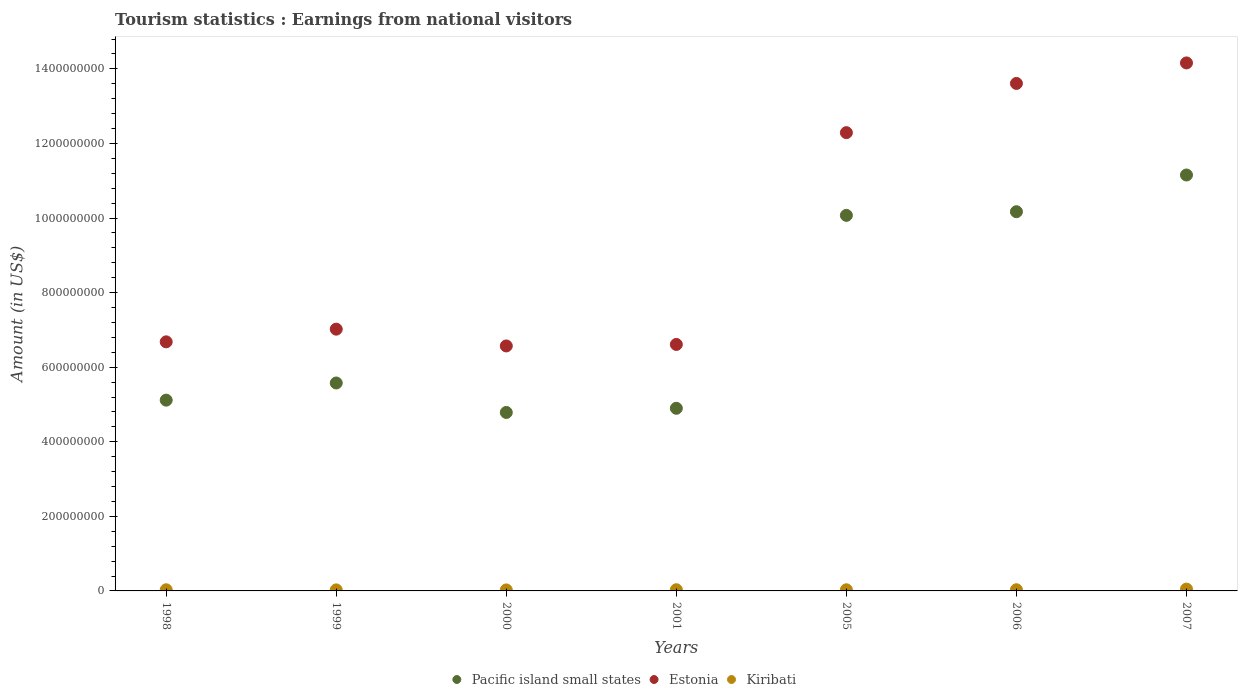How many different coloured dotlines are there?
Provide a short and direct response. 3. What is the earnings from national visitors in Pacific island small states in 2006?
Ensure brevity in your answer.  1.02e+09. Across all years, what is the maximum earnings from national visitors in Pacific island small states?
Keep it short and to the point. 1.12e+09. Across all years, what is the minimum earnings from national visitors in Estonia?
Your answer should be compact. 6.57e+08. In which year was the earnings from national visitors in Estonia maximum?
Offer a very short reply. 2007. In which year was the earnings from national visitors in Pacific island small states minimum?
Your response must be concise. 2000. What is the total earnings from national visitors in Estonia in the graph?
Offer a terse response. 6.69e+09. What is the difference between the earnings from national visitors in Pacific island small states in 1998 and that in 2006?
Ensure brevity in your answer.  -5.05e+08. What is the difference between the earnings from national visitors in Pacific island small states in 1998 and the earnings from national visitors in Kiribati in 2005?
Offer a very short reply. 5.09e+08. What is the average earnings from national visitors in Pacific island small states per year?
Your answer should be very brief. 7.40e+08. In the year 2000, what is the difference between the earnings from national visitors in Estonia and earnings from national visitors in Kiribati?
Your answer should be compact. 6.54e+08. What is the ratio of the earnings from national visitors in Estonia in 1999 to that in 2000?
Offer a terse response. 1.07. Is the difference between the earnings from national visitors in Estonia in 1998 and 2007 greater than the difference between the earnings from national visitors in Kiribati in 1998 and 2007?
Offer a terse response. No. What is the difference between the highest and the second highest earnings from national visitors in Estonia?
Your answer should be compact. 5.50e+07. What is the difference between the highest and the lowest earnings from national visitors in Estonia?
Provide a succinct answer. 7.59e+08. Is the sum of the earnings from national visitors in Estonia in 2000 and 2006 greater than the maximum earnings from national visitors in Pacific island small states across all years?
Give a very brief answer. Yes. Is the earnings from national visitors in Kiribati strictly greater than the earnings from national visitors in Estonia over the years?
Your answer should be compact. No. Is the earnings from national visitors in Estonia strictly less than the earnings from national visitors in Kiribati over the years?
Make the answer very short. No. What is the difference between two consecutive major ticks on the Y-axis?
Your answer should be very brief. 2.00e+08. Are the values on the major ticks of Y-axis written in scientific E-notation?
Provide a short and direct response. No. Where does the legend appear in the graph?
Offer a very short reply. Bottom center. How many legend labels are there?
Your answer should be very brief. 3. How are the legend labels stacked?
Make the answer very short. Horizontal. What is the title of the graph?
Give a very brief answer. Tourism statistics : Earnings from national visitors. What is the Amount (in US$) of Pacific island small states in 1998?
Give a very brief answer. 5.12e+08. What is the Amount (in US$) of Estonia in 1998?
Your response must be concise. 6.68e+08. What is the Amount (in US$) in Kiribati in 1998?
Keep it short and to the point. 3.10e+06. What is the Amount (in US$) in Pacific island small states in 1999?
Your response must be concise. 5.58e+08. What is the Amount (in US$) in Estonia in 1999?
Keep it short and to the point. 7.02e+08. What is the Amount (in US$) in Kiribati in 1999?
Offer a very short reply. 2.80e+06. What is the Amount (in US$) in Pacific island small states in 2000?
Keep it short and to the point. 4.79e+08. What is the Amount (in US$) of Estonia in 2000?
Make the answer very short. 6.57e+08. What is the Amount (in US$) of Kiribati in 2000?
Keep it short and to the point. 2.70e+06. What is the Amount (in US$) in Pacific island small states in 2001?
Ensure brevity in your answer.  4.90e+08. What is the Amount (in US$) of Estonia in 2001?
Give a very brief answer. 6.61e+08. What is the Amount (in US$) in Kiribati in 2001?
Offer a very short reply. 3.20e+06. What is the Amount (in US$) of Pacific island small states in 2005?
Offer a very short reply. 1.01e+09. What is the Amount (in US$) in Estonia in 2005?
Provide a short and direct response. 1.23e+09. What is the Amount (in US$) in Kiribati in 2005?
Provide a short and direct response. 3.10e+06. What is the Amount (in US$) in Pacific island small states in 2006?
Provide a succinct answer. 1.02e+09. What is the Amount (in US$) in Estonia in 2006?
Offer a very short reply. 1.36e+09. What is the Amount (in US$) of Kiribati in 2006?
Provide a succinct answer. 3.20e+06. What is the Amount (in US$) in Pacific island small states in 2007?
Offer a very short reply. 1.12e+09. What is the Amount (in US$) in Estonia in 2007?
Make the answer very short. 1.42e+09. What is the Amount (in US$) of Kiribati in 2007?
Your response must be concise. 4.90e+06. Across all years, what is the maximum Amount (in US$) of Pacific island small states?
Keep it short and to the point. 1.12e+09. Across all years, what is the maximum Amount (in US$) in Estonia?
Give a very brief answer. 1.42e+09. Across all years, what is the maximum Amount (in US$) in Kiribati?
Ensure brevity in your answer.  4.90e+06. Across all years, what is the minimum Amount (in US$) in Pacific island small states?
Your answer should be compact. 4.79e+08. Across all years, what is the minimum Amount (in US$) in Estonia?
Provide a short and direct response. 6.57e+08. Across all years, what is the minimum Amount (in US$) of Kiribati?
Keep it short and to the point. 2.70e+06. What is the total Amount (in US$) in Pacific island small states in the graph?
Provide a short and direct response. 5.18e+09. What is the total Amount (in US$) in Estonia in the graph?
Make the answer very short. 6.69e+09. What is the total Amount (in US$) of Kiribati in the graph?
Provide a succinct answer. 2.30e+07. What is the difference between the Amount (in US$) in Pacific island small states in 1998 and that in 1999?
Provide a succinct answer. -4.60e+07. What is the difference between the Amount (in US$) in Estonia in 1998 and that in 1999?
Your response must be concise. -3.40e+07. What is the difference between the Amount (in US$) of Pacific island small states in 1998 and that in 2000?
Ensure brevity in your answer.  3.30e+07. What is the difference between the Amount (in US$) of Estonia in 1998 and that in 2000?
Your answer should be compact. 1.10e+07. What is the difference between the Amount (in US$) of Kiribati in 1998 and that in 2000?
Keep it short and to the point. 4.00e+05. What is the difference between the Amount (in US$) of Pacific island small states in 1998 and that in 2001?
Ensure brevity in your answer.  2.19e+07. What is the difference between the Amount (in US$) in Estonia in 1998 and that in 2001?
Offer a terse response. 7.00e+06. What is the difference between the Amount (in US$) of Kiribati in 1998 and that in 2001?
Your answer should be compact. -1.00e+05. What is the difference between the Amount (in US$) of Pacific island small states in 1998 and that in 2005?
Ensure brevity in your answer.  -4.96e+08. What is the difference between the Amount (in US$) in Estonia in 1998 and that in 2005?
Ensure brevity in your answer.  -5.61e+08. What is the difference between the Amount (in US$) of Pacific island small states in 1998 and that in 2006?
Make the answer very short. -5.05e+08. What is the difference between the Amount (in US$) of Estonia in 1998 and that in 2006?
Ensure brevity in your answer.  -6.93e+08. What is the difference between the Amount (in US$) in Kiribati in 1998 and that in 2006?
Make the answer very short. -1.00e+05. What is the difference between the Amount (in US$) in Pacific island small states in 1998 and that in 2007?
Make the answer very short. -6.04e+08. What is the difference between the Amount (in US$) of Estonia in 1998 and that in 2007?
Your answer should be very brief. -7.48e+08. What is the difference between the Amount (in US$) of Kiribati in 1998 and that in 2007?
Offer a very short reply. -1.80e+06. What is the difference between the Amount (in US$) in Pacific island small states in 1999 and that in 2000?
Make the answer very short. 7.90e+07. What is the difference between the Amount (in US$) of Estonia in 1999 and that in 2000?
Provide a succinct answer. 4.50e+07. What is the difference between the Amount (in US$) of Pacific island small states in 1999 and that in 2001?
Your answer should be very brief. 6.78e+07. What is the difference between the Amount (in US$) in Estonia in 1999 and that in 2001?
Provide a short and direct response. 4.10e+07. What is the difference between the Amount (in US$) of Kiribati in 1999 and that in 2001?
Make the answer very short. -4.00e+05. What is the difference between the Amount (in US$) of Pacific island small states in 1999 and that in 2005?
Offer a very short reply. -4.50e+08. What is the difference between the Amount (in US$) in Estonia in 1999 and that in 2005?
Offer a very short reply. -5.27e+08. What is the difference between the Amount (in US$) in Pacific island small states in 1999 and that in 2006?
Your answer should be very brief. -4.59e+08. What is the difference between the Amount (in US$) in Estonia in 1999 and that in 2006?
Keep it short and to the point. -6.59e+08. What is the difference between the Amount (in US$) in Kiribati in 1999 and that in 2006?
Offer a terse response. -4.00e+05. What is the difference between the Amount (in US$) of Pacific island small states in 1999 and that in 2007?
Your response must be concise. -5.58e+08. What is the difference between the Amount (in US$) in Estonia in 1999 and that in 2007?
Ensure brevity in your answer.  -7.14e+08. What is the difference between the Amount (in US$) of Kiribati in 1999 and that in 2007?
Offer a terse response. -2.10e+06. What is the difference between the Amount (in US$) of Pacific island small states in 2000 and that in 2001?
Your answer should be very brief. -1.12e+07. What is the difference between the Amount (in US$) of Kiribati in 2000 and that in 2001?
Provide a succinct answer. -5.00e+05. What is the difference between the Amount (in US$) in Pacific island small states in 2000 and that in 2005?
Your response must be concise. -5.29e+08. What is the difference between the Amount (in US$) in Estonia in 2000 and that in 2005?
Keep it short and to the point. -5.72e+08. What is the difference between the Amount (in US$) of Kiribati in 2000 and that in 2005?
Your answer should be very brief. -4.00e+05. What is the difference between the Amount (in US$) of Pacific island small states in 2000 and that in 2006?
Your answer should be very brief. -5.38e+08. What is the difference between the Amount (in US$) in Estonia in 2000 and that in 2006?
Your response must be concise. -7.04e+08. What is the difference between the Amount (in US$) in Kiribati in 2000 and that in 2006?
Offer a terse response. -5.00e+05. What is the difference between the Amount (in US$) of Pacific island small states in 2000 and that in 2007?
Provide a short and direct response. -6.37e+08. What is the difference between the Amount (in US$) of Estonia in 2000 and that in 2007?
Your response must be concise. -7.59e+08. What is the difference between the Amount (in US$) in Kiribati in 2000 and that in 2007?
Offer a very short reply. -2.20e+06. What is the difference between the Amount (in US$) of Pacific island small states in 2001 and that in 2005?
Keep it short and to the point. -5.17e+08. What is the difference between the Amount (in US$) in Estonia in 2001 and that in 2005?
Keep it short and to the point. -5.68e+08. What is the difference between the Amount (in US$) of Kiribati in 2001 and that in 2005?
Keep it short and to the point. 1.00e+05. What is the difference between the Amount (in US$) in Pacific island small states in 2001 and that in 2006?
Provide a succinct answer. -5.27e+08. What is the difference between the Amount (in US$) of Estonia in 2001 and that in 2006?
Your answer should be compact. -7.00e+08. What is the difference between the Amount (in US$) in Pacific island small states in 2001 and that in 2007?
Ensure brevity in your answer.  -6.26e+08. What is the difference between the Amount (in US$) of Estonia in 2001 and that in 2007?
Ensure brevity in your answer.  -7.55e+08. What is the difference between the Amount (in US$) of Kiribati in 2001 and that in 2007?
Your answer should be very brief. -1.70e+06. What is the difference between the Amount (in US$) in Pacific island small states in 2005 and that in 2006?
Ensure brevity in your answer.  -9.77e+06. What is the difference between the Amount (in US$) of Estonia in 2005 and that in 2006?
Your answer should be very brief. -1.32e+08. What is the difference between the Amount (in US$) of Kiribati in 2005 and that in 2006?
Provide a short and direct response. -1.00e+05. What is the difference between the Amount (in US$) in Pacific island small states in 2005 and that in 2007?
Offer a very short reply. -1.08e+08. What is the difference between the Amount (in US$) of Estonia in 2005 and that in 2007?
Give a very brief answer. -1.87e+08. What is the difference between the Amount (in US$) of Kiribati in 2005 and that in 2007?
Keep it short and to the point. -1.80e+06. What is the difference between the Amount (in US$) of Pacific island small states in 2006 and that in 2007?
Your response must be concise. -9.85e+07. What is the difference between the Amount (in US$) in Estonia in 2006 and that in 2007?
Ensure brevity in your answer.  -5.50e+07. What is the difference between the Amount (in US$) in Kiribati in 2006 and that in 2007?
Give a very brief answer. -1.70e+06. What is the difference between the Amount (in US$) of Pacific island small states in 1998 and the Amount (in US$) of Estonia in 1999?
Your answer should be compact. -1.90e+08. What is the difference between the Amount (in US$) of Pacific island small states in 1998 and the Amount (in US$) of Kiribati in 1999?
Ensure brevity in your answer.  5.09e+08. What is the difference between the Amount (in US$) of Estonia in 1998 and the Amount (in US$) of Kiribati in 1999?
Provide a short and direct response. 6.65e+08. What is the difference between the Amount (in US$) in Pacific island small states in 1998 and the Amount (in US$) in Estonia in 2000?
Your response must be concise. -1.45e+08. What is the difference between the Amount (in US$) in Pacific island small states in 1998 and the Amount (in US$) in Kiribati in 2000?
Your answer should be very brief. 5.09e+08. What is the difference between the Amount (in US$) in Estonia in 1998 and the Amount (in US$) in Kiribati in 2000?
Your answer should be compact. 6.65e+08. What is the difference between the Amount (in US$) of Pacific island small states in 1998 and the Amount (in US$) of Estonia in 2001?
Provide a short and direct response. -1.49e+08. What is the difference between the Amount (in US$) in Pacific island small states in 1998 and the Amount (in US$) in Kiribati in 2001?
Keep it short and to the point. 5.08e+08. What is the difference between the Amount (in US$) of Estonia in 1998 and the Amount (in US$) of Kiribati in 2001?
Keep it short and to the point. 6.65e+08. What is the difference between the Amount (in US$) in Pacific island small states in 1998 and the Amount (in US$) in Estonia in 2005?
Make the answer very short. -7.17e+08. What is the difference between the Amount (in US$) in Pacific island small states in 1998 and the Amount (in US$) in Kiribati in 2005?
Your response must be concise. 5.09e+08. What is the difference between the Amount (in US$) in Estonia in 1998 and the Amount (in US$) in Kiribati in 2005?
Make the answer very short. 6.65e+08. What is the difference between the Amount (in US$) of Pacific island small states in 1998 and the Amount (in US$) of Estonia in 2006?
Keep it short and to the point. -8.49e+08. What is the difference between the Amount (in US$) in Pacific island small states in 1998 and the Amount (in US$) in Kiribati in 2006?
Offer a very short reply. 5.08e+08. What is the difference between the Amount (in US$) of Estonia in 1998 and the Amount (in US$) of Kiribati in 2006?
Your response must be concise. 6.65e+08. What is the difference between the Amount (in US$) of Pacific island small states in 1998 and the Amount (in US$) of Estonia in 2007?
Keep it short and to the point. -9.04e+08. What is the difference between the Amount (in US$) of Pacific island small states in 1998 and the Amount (in US$) of Kiribati in 2007?
Your response must be concise. 5.07e+08. What is the difference between the Amount (in US$) in Estonia in 1998 and the Amount (in US$) in Kiribati in 2007?
Provide a succinct answer. 6.63e+08. What is the difference between the Amount (in US$) in Pacific island small states in 1999 and the Amount (in US$) in Estonia in 2000?
Keep it short and to the point. -9.94e+07. What is the difference between the Amount (in US$) of Pacific island small states in 1999 and the Amount (in US$) of Kiribati in 2000?
Give a very brief answer. 5.55e+08. What is the difference between the Amount (in US$) in Estonia in 1999 and the Amount (in US$) in Kiribati in 2000?
Your response must be concise. 6.99e+08. What is the difference between the Amount (in US$) of Pacific island small states in 1999 and the Amount (in US$) of Estonia in 2001?
Your answer should be compact. -1.03e+08. What is the difference between the Amount (in US$) of Pacific island small states in 1999 and the Amount (in US$) of Kiribati in 2001?
Make the answer very short. 5.54e+08. What is the difference between the Amount (in US$) of Estonia in 1999 and the Amount (in US$) of Kiribati in 2001?
Provide a succinct answer. 6.99e+08. What is the difference between the Amount (in US$) of Pacific island small states in 1999 and the Amount (in US$) of Estonia in 2005?
Provide a short and direct response. -6.71e+08. What is the difference between the Amount (in US$) of Pacific island small states in 1999 and the Amount (in US$) of Kiribati in 2005?
Ensure brevity in your answer.  5.55e+08. What is the difference between the Amount (in US$) of Estonia in 1999 and the Amount (in US$) of Kiribati in 2005?
Offer a terse response. 6.99e+08. What is the difference between the Amount (in US$) of Pacific island small states in 1999 and the Amount (in US$) of Estonia in 2006?
Give a very brief answer. -8.03e+08. What is the difference between the Amount (in US$) of Pacific island small states in 1999 and the Amount (in US$) of Kiribati in 2006?
Make the answer very short. 5.54e+08. What is the difference between the Amount (in US$) in Estonia in 1999 and the Amount (in US$) in Kiribati in 2006?
Make the answer very short. 6.99e+08. What is the difference between the Amount (in US$) in Pacific island small states in 1999 and the Amount (in US$) in Estonia in 2007?
Provide a short and direct response. -8.58e+08. What is the difference between the Amount (in US$) in Pacific island small states in 1999 and the Amount (in US$) in Kiribati in 2007?
Provide a succinct answer. 5.53e+08. What is the difference between the Amount (in US$) in Estonia in 1999 and the Amount (in US$) in Kiribati in 2007?
Offer a very short reply. 6.97e+08. What is the difference between the Amount (in US$) of Pacific island small states in 2000 and the Amount (in US$) of Estonia in 2001?
Give a very brief answer. -1.82e+08. What is the difference between the Amount (in US$) of Pacific island small states in 2000 and the Amount (in US$) of Kiribati in 2001?
Keep it short and to the point. 4.75e+08. What is the difference between the Amount (in US$) of Estonia in 2000 and the Amount (in US$) of Kiribati in 2001?
Give a very brief answer. 6.54e+08. What is the difference between the Amount (in US$) in Pacific island small states in 2000 and the Amount (in US$) in Estonia in 2005?
Give a very brief answer. -7.50e+08. What is the difference between the Amount (in US$) of Pacific island small states in 2000 and the Amount (in US$) of Kiribati in 2005?
Offer a very short reply. 4.76e+08. What is the difference between the Amount (in US$) of Estonia in 2000 and the Amount (in US$) of Kiribati in 2005?
Ensure brevity in your answer.  6.54e+08. What is the difference between the Amount (in US$) of Pacific island small states in 2000 and the Amount (in US$) of Estonia in 2006?
Make the answer very short. -8.82e+08. What is the difference between the Amount (in US$) of Pacific island small states in 2000 and the Amount (in US$) of Kiribati in 2006?
Your response must be concise. 4.75e+08. What is the difference between the Amount (in US$) in Estonia in 2000 and the Amount (in US$) in Kiribati in 2006?
Your answer should be compact. 6.54e+08. What is the difference between the Amount (in US$) of Pacific island small states in 2000 and the Amount (in US$) of Estonia in 2007?
Offer a very short reply. -9.37e+08. What is the difference between the Amount (in US$) in Pacific island small states in 2000 and the Amount (in US$) in Kiribati in 2007?
Keep it short and to the point. 4.74e+08. What is the difference between the Amount (in US$) of Estonia in 2000 and the Amount (in US$) of Kiribati in 2007?
Keep it short and to the point. 6.52e+08. What is the difference between the Amount (in US$) of Pacific island small states in 2001 and the Amount (in US$) of Estonia in 2005?
Make the answer very short. -7.39e+08. What is the difference between the Amount (in US$) in Pacific island small states in 2001 and the Amount (in US$) in Kiribati in 2005?
Make the answer very short. 4.87e+08. What is the difference between the Amount (in US$) of Estonia in 2001 and the Amount (in US$) of Kiribati in 2005?
Make the answer very short. 6.58e+08. What is the difference between the Amount (in US$) of Pacific island small states in 2001 and the Amount (in US$) of Estonia in 2006?
Your answer should be very brief. -8.71e+08. What is the difference between the Amount (in US$) in Pacific island small states in 2001 and the Amount (in US$) in Kiribati in 2006?
Provide a succinct answer. 4.87e+08. What is the difference between the Amount (in US$) of Estonia in 2001 and the Amount (in US$) of Kiribati in 2006?
Ensure brevity in your answer.  6.58e+08. What is the difference between the Amount (in US$) of Pacific island small states in 2001 and the Amount (in US$) of Estonia in 2007?
Your answer should be very brief. -9.26e+08. What is the difference between the Amount (in US$) of Pacific island small states in 2001 and the Amount (in US$) of Kiribati in 2007?
Give a very brief answer. 4.85e+08. What is the difference between the Amount (in US$) in Estonia in 2001 and the Amount (in US$) in Kiribati in 2007?
Give a very brief answer. 6.56e+08. What is the difference between the Amount (in US$) in Pacific island small states in 2005 and the Amount (in US$) in Estonia in 2006?
Your answer should be very brief. -3.54e+08. What is the difference between the Amount (in US$) of Pacific island small states in 2005 and the Amount (in US$) of Kiribati in 2006?
Provide a succinct answer. 1.00e+09. What is the difference between the Amount (in US$) in Estonia in 2005 and the Amount (in US$) in Kiribati in 2006?
Offer a terse response. 1.23e+09. What is the difference between the Amount (in US$) of Pacific island small states in 2005 and the Amount (in US$) of Estonia in 2007?
Give a very brief answer. -4.09e+08. What is the difference between the Amount (in US$) of Pacific island small states in 2005 and the Amount (in US$) of Kiribati in 2007?
Provide a short and direct response. 1.00e+09. What is the difference between the Amount (in US$) in Estonia in 2005 and the Amount (in US$) in Kiribati in 2007?
Offer a terse response. 1.22e+09. What is the difference between the Amount (in US$) of Pacific island small states in 2006 and the Amount (in US$) of Estonia in 2007?
Make the answer very short. -3.99e+08. What is the difference between the Amount (in US$) in Pacific island small states in 2006 and the Amount (in US$) in Kiribati in 2007?
Provide a succinct answer. 1.01e+09. What is the difference between the Amount (in US$) in Estonia in 2006 and the Amount (in US$) in Kiribati in 2007?
Offer a very short reply. 1.36e+09. What is the average Amount (in US$) in Pacific island small states per year?
Your answer should be compact. 7.40e+08. What is the average Amount (in US$) of Estonia per year?
Your response must be concise. 9.56e+08. What is the average Amount (in US$) of Kiribati per year?
Provide a succinct answer. 3.29e+06. In the year 1998, what is the difference between the Amount (in US$) of Pacific island small states and Amount (in US$) of Estonia?
Provide a short and direct response. -1.56e+08. In the year 1998, what is the difference between the Amount (in US$) of Pacific island small states and Amount (in US$) of Kiribati?
Your answer should be very brief. 5.09e+08. In the year 1998, what is the difference between the Amount (in US$) of Estonia and Amount (in US$) of Kiribati?
Make the answer very short. 6.65e+08. In the year 1999, what is the difference between the Amount (in US$) in Pacific island small states and Amount (in US$) in Estonia?
Make the answer very short. -1.44e+08. In the year 1999, what is the difference between the Amount (in US$) of Pacific island small states and Amount (in US$) of Kiribati?
Offer a terse response. 5.55e+08. In the year 1999, what is the difference between the Amount (in US$) in Estonia and Amount (in US$) in Kiribati?
Give a very brief answer. 6.99e+08. In the year 2000, what is the difference between the Amount (in US$) in Pacific island small states and Amount (in US$) in Estonia?
Offer a terse response. -1.78e+08. In the year 2000, what is the difference between the Amount (in US$) of Pacific island small states and Amount (in US$) of Kiribati?
Your response must be concise. 4.76e+08. In the year 2000, what is the difference between the Amount (in US$) of Estonia and Amount (in US$) of Kiribati?
Keep it short and to the point. 6.54e+08. In the year 2001, what is the difference between the Amount (in US$) in Pacific island small states and Amount (in US$) in Estonia?
Offer a very short reply. -1.71e+08. In the year 2001, what is the difference between the Amount (in US$) of Pacific island small states and Amount (in US$) of Kiribati?
Make the answer very short. 4.87e+08. In the year 2001, what is the difference between the Amount (in US$) in Estonia and Amount (in US$) in Kiribati?
Provide a short and direct response. 6.58e+08. In the year 2005, what is the difference between the Amount (in US$) of Pacific island small states and Amount (in US$) of Estonia?
Your answer should be very brief. -2.22e+08. In the year 2005, what is the difference between the Amount (in US$) of Pacific island small states and Amount (in US$) of Kiribati?
Offer a terse response. 1.00e+09. In the year 2005, what is the difference between the Amount (in US$) in Estonia and Amount (in US$) in Kiribati?
Your response must be concise. 1.23e+09. In the year 2006, what is the difference between the Amount (in US$) of Pacific island small states and Amount (in US$) of Estonia?
Your response must be concise. -3.44e+08. In the year 2006, what is the difference between the Amount (in US$) of Pacific island small states and Amount (in US$) of Kiribati?
Offer a very short reply. 1.01e+09. In the year 2006, what is the difference between the Amount (in US$) of Estonia and Amount (in US$) of Kiribati?
Provide a short and direct response. 1.36e+09. In the year 2007, what is the difference between the Amount (in US$) of Pacific island small states and Amount (in US$) of Estonia?
Your answer should be compact. -3.01e+08. In the year 2007, what is the difference between the Amount (in US$) of Pacific island small states and Amount (in US$) of Kiribati?
Keep it short and to the point. 1.11e+09. In the year 2007, what is the difference between the Amount (in US$) in Estonia and Amount (in US$) in Kiribati?
Keep it short and to the point. 1.41e+09. What is the ratio of the Amount (in US$) in Pacific island small states in 1998 to that in 1999?
Offer a very short reply. 0.92. What is the ratio of the Amount (in US$) in Estonia in 1998 to that in 1999?
Make the answer very short. 0.95. What is the ratio of the Amount (in US$) of Kiribati in 1998 to that in 1999?
Your response must be concise. 1.11. What is the ratio of the Amount (in US$) of Pacific island small states in 1998 to that in 2000?
Keep it short and to the point. 1.07. What is the ratio of the Amount (in US$) in Estonia in 1998 to that in 2000?
Make the answer very short. 1.02. What is the ratio of the Amount (in US$) of Kiribati in 1998 to that in 2000?
Make the answer very short. 1.15. What is the ratio of the Amount (in US$) in Pacific island small states in 1998 to that in 2001?
Your answer should be compact. 1.04. What is the ratio of the Amount (in US$) of Estonia in 1998 to that in 2001?
Keep it short and to the point. 1.01. What is the ratio of the Amount (in US$) of Kiribati in 1998 to that in 2001?
Provide a succinct answer. 0.97. What is the ratio of the Amount (in US$) in Pacific island small states in 1998 to that in 2005?
Ensure brevity in your answer.  0.51. What is the ratio of the Amount (in US$) of Estonia in 1998 to that in 2005?
Offer a very short reply. 0.54. What is the ratio of the Amount (in US$) in Pacific island small states in 1998 to that in 2006?
Provide a short and direct response. 0.5. What is the ratio of the Amount (in US$) in Estonia in 1998 to that in 2006?
Offer a terse response. 0.49. What is the ratio of the Amount (in US$) of Kiribati in 1998 to that in 2006?
Your answer should be compact. 0.97. What is the ratio of the Amount (in US$) in Pacific island small states in 1998 to that in 2007?
Your answer should be compact. 0.46. What is the ratio of the Amount (in US$) of Estonia in 1998 to that in 2007?
Offer a terse response. 0.47. What is the ratio of the Amount (in US$) of Kiribati in 1998 to that in 2007?
Offer a very short reply. 0.63. What is the ratio of the Amount (in US$) of Pacific island small states in 1999 to that in 2000?
Provide a succinct answer. 1.17. What is the ratio of the Amount (in US$) of Estonia in 1999 to that in 2000?
Provide a succinct answer. 1.07. What is the ratio of the Amount (in US$) of Kiribati in 1999 to that in 2000?
Offer a very short reply. 1.04. What is the ratio of the Amount (in US$) of Pacific island small states in 1999 to that in 2001?
Your answer should be very brief. 1.14. What is the ratio of the Amount (in US$) in Estonia in 1999 to that in 2001?
Your answer should be very brief. 1.06. What is the ratio of the Amount (in US$) in Kiribati in 1999 to that in 2001?
Your answer should be very brief. 0.88. What is the ratio of the Amount (in US$) of Pacific island small states in 1999 to that in 2005?
Offer a very short reply. 0.55. What is the ratio of the Amount (in US$) in Estonia in 1999 to that in 2005?
Give a very brief answer. 0.57. What is the ratio of the Amount (in US$) of Kiribati in 1999 to that in 2005?
Offer a very short reply. 0.9. What is the ratio of the Amount (in US$) in Pacific island small states in 1999 to that in 2006?
Provide a short and direct response. 0.55. What is the ratio of the Amount (in US$) of Estonia in 1999 to that in 2006?
Your answer should be compact. 0.52. What is the ratio of the Amount (in US$) in Kiribati in 1999 to that in 2006?
Give a very brief answer. 0.88. What is the ratio of the Amount (in US$) of Pacific island small states in 1999 to that in 2007?
Ensure brevity in your answer.  0.5. What is the ratio of the Amount (in US$) of Estonia in 1999 to that in 2007?
Give a very brief answer. 0.5. What is the ratio of the Amount (in US$) of Kiribati in 1999 to that in 2007?
Give a very brief answer. 0.57. What is the ratio of the Amount (in US$) of Pacific island small states in 2000 to that in 2001?
Offer a very short reply. 0.98. What is the ratio of the Amount (in US$) in Kiribati in 2000 to that in 2001?
Keep it short and to the point. 0.84. What is the ratio of the Amount (in US$) of Pacific island small states in 2000 to that in 2005?
Provide a short and direct response. 0.48. What is the ratio of the Amount (in US$) of Estonia in 2000 to that in 2005?
Your response must be concise. 0.53. What is the ratio of the Amount (in US$) in Kiribati in 2000 to that in 2005?
Give a very brief answer. 0.87. What is the ratio of the Amount (in US$) in Pacific island small states in 2000 to that in 2006?
Offer a terse response. 0.47. What is the ratio of the Amount (in US$) of Estonia in 2000 to that in 2006?
Offer a very short reply. 0.48. What is the ratio of the Amount (in US$) in Kiribati in 2000 to that in 2006?
Your answer should be compact. 0.84. What is the ratio of the Amount (in US$) of Pacific island small states in 2000 to that in 2007?
Give a very brief answer. 0.43. What is the ratio of the Amount (in US$) in Estonia in 2000 to that in 2007?
Your response must be concise. 0.46. What is the ratio of the Amount (in US$) in Kiribati in 2000 to that in 2007?
Ensure brevity in your answer.  0.55. What is the ratio of the Amount (in US$) of Pacific island small states in 2001 to that in 2005?
Ensure brevity in your answer.  0.49. What is the ratio of the Amount (in US$) in Estonia in 2001 to that in 2005?
Your response must be concise. 0.54. What is the ratio of the Amount (in US$) in Kiribati in 2001 to that in 2005?
Give a very brief answer. 1.03. What is the ratio of the Amount (in US$) of Pacific island small states in 2001 to that in 2006?
Provide a short and direct response. 0.48. What is the ratio of the Amount (in US$) of Estonia in 2001 to that in 2006?
Your answer should be compact. 0.49. What is the ratio of the Amount (in US$) of Kiribati in 2001 to that in 2006?
Your answer should be very brief. 1. What is the ratio of the Amount (in US$) in Pacific island small states in 2001 to that in 2007?
Offer a terse response. 0.44. What is the ratio of the Amount (in US$) in Estonia in 2001 to that in 2007?
Give a very brief answer. 0.47. What is the ratio of the Amount (in US$) in Kiribati in 2001 to that in 2007?
Make the answer very short. 0.65. What is the ratio of the Amount (in US$) in Estonia in 2005 to that in 2006?
Your answer should be very brief. 0.9. What is the ratio of the Amount (in US$) in Kiribati in 2005 to that in 2006?
Provide a short and direct response. 0.97. What is the ratio of the Amount (in US$) of Pacific island small states in 2005 to that in 2007?
Offer a very short reply. 0.9. What is the ratio of the Amount (in US$) in Estonia in 2005 to that in 2007?
Give a very brief answer. 0.87. What is the ratio of the Amount (in US$) in Kiribati in 2005 to that in 2007?
Provide a short and direct response. 0.63. What is the ratio of the Amount (in US$) in Pacific island small states in 2006 to that in 2007?
Your response must be concise. 0.91. What is the ratio of the Amount (in US$) of Estonia in 2006 to that in 2007?
Your response must be concise. 0.96. What is the ratio of the Amount (in US$) of Kiribati in 2006 to that in 2007?
Make the answer very short. 0.65. What is the difference between the highest and the second highest Amount (in US$) in Pacific island small states?
Keep it short and to the point. 9.85e+07. What is the difference between the highest and the second highest Amount (in US$) of Estonia?
Ensure brevity in your answer.  5.50e+07. What is the difference between the highest and the second highest Amount (in US$) in Kiribati?
Provide a short and direct response. 1.70e+06. What is the difference between the highest and the lowest Amount (in US$) of Pacific island small states?
Provide a succinct answer. 6.37e+08. What is the difference between the highest and the lowest Amount (in US$) in Estonia?
Your response must be concise. 7.59e+08. What is the difference between the highest and the lowest Amount (in US$) in Kiribati?
Offer a very short reply. 2.20e+06. 